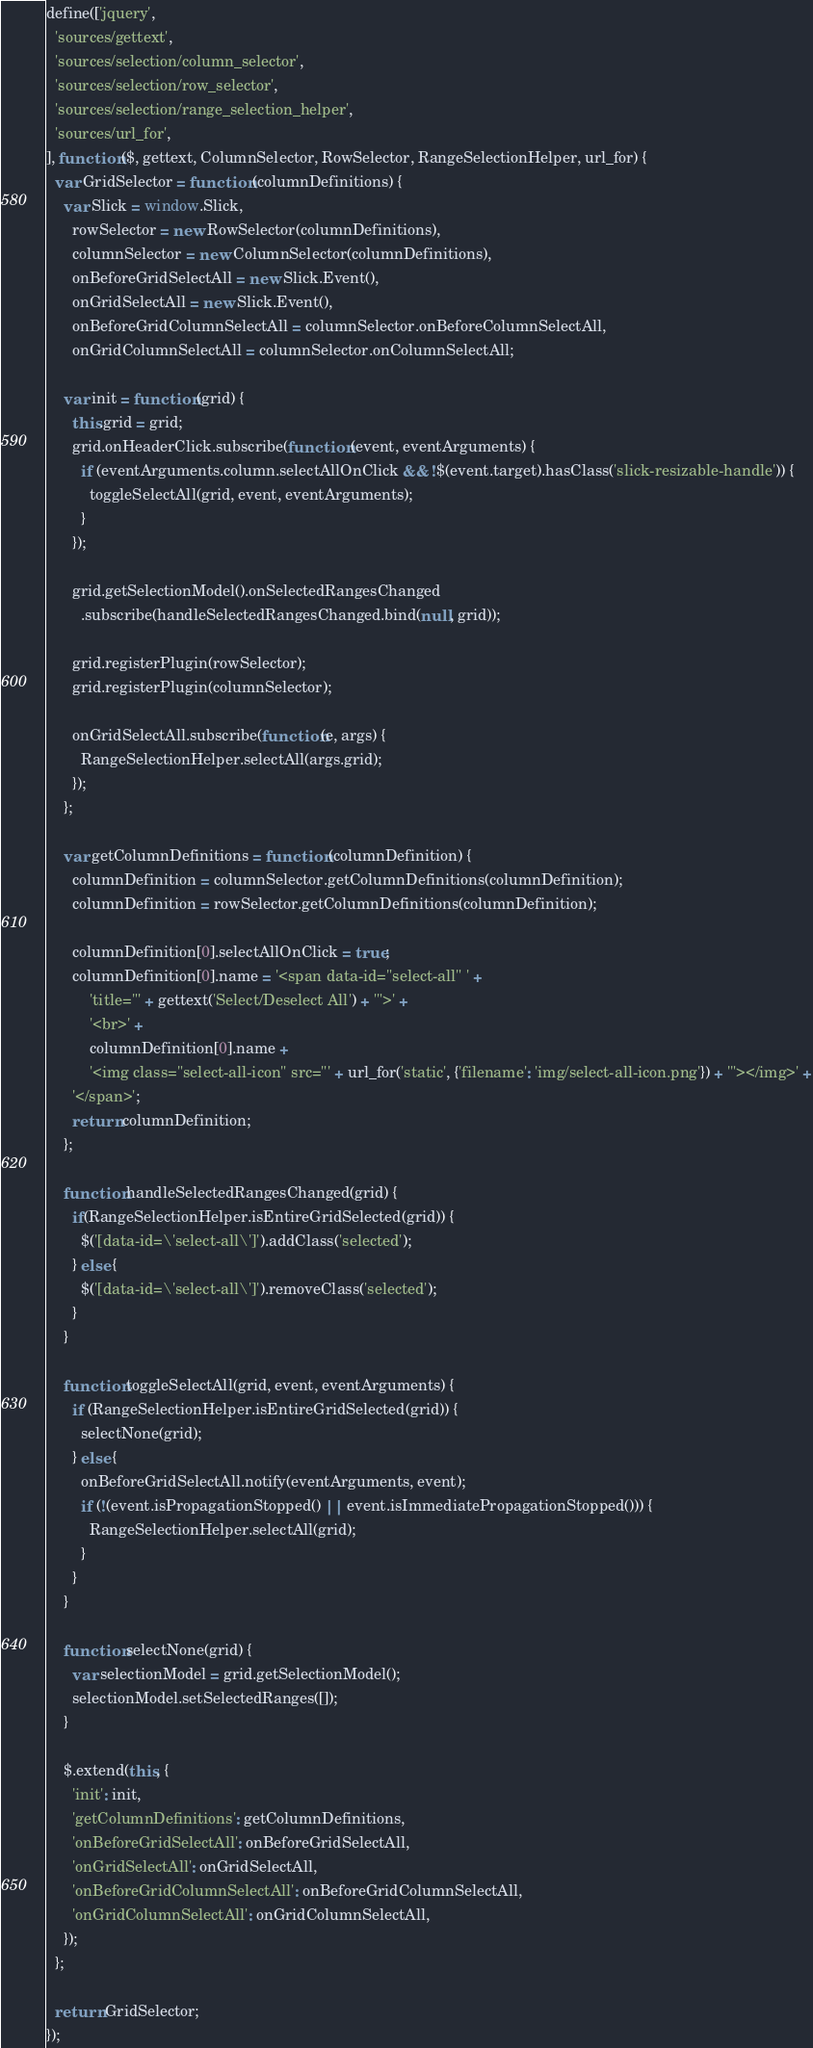Convert code to text. <code><loc_0><loc_0><loc_500><loc_500><_JavaScript_>
define(['jquery',
  'sources/gettext',
  'sources/selection/column_selector',
  'sources/selection/row_selector',
  'sources/selection/range_selection_helper',
  'sources/url_for',
], function ($, gettext, ColumnSelector, RowSelector, RangeSelectionHelper, url_for) {
  var GridSelector = function (columnDefinitions) {
    var Slick = window.Slick,
      rowSelector = new RowSelector(columnDefinitions),
      columnSelector = new ColumnSelector(columnDefinitions),
      onBeforeGridSelectAll = new Slick.Event(),
      onGridSelectAll = new Slick.Event(),
      onBeforeGridColumnSelectAll = columnSelector.onBeforeColumnSelectAll,
      onGridColumnSelectAll = columnSelector.onColumnSelectAll;

    var init = function (grid) {
      this.grid = grid;
      grid.onHeaderClick.subscribe(function (event, eventArguments) {
        if (eventArguments.column.selectAllOnClick && !$(event.target).hasClass('slick-resizable-handle')) {
          toggleSelectAll(grid, event, eventArguments);
        }
      });

      grid.getSelectionModel().onSelectedRangesChanged
        .subscribe(handleSelectedRangesChanged.bind(null, grid));

      grid.registerPlugin(rowSelector);
      grid.registerPlugin(columnSelector);

      onGridSelectAll.subscribe(function(e, args) {
        RangeSelectionHelper.selectAll(args.grid);
      });
    };

    var getColumnDefinitions = function (columnDefinition) {
      columnDefinition = columnSelector.getColumnDefinitions(columnDefinition);
      columnDefinition = rowSelector.getColumnDefinitions(columnDefinition);

      columnDefinition[0].selectAllOnClick = true;
      columnDefinition[0].name = '<span data-id="select-all" ' +
          'title="' + gettext('Select/Deselect All') + '">' +
          '<br>' +
          columnDefinition[0].name +
          '<img class="select-all-icon" src="' + url_for('static', {'filename': 'img/select-all-icon.png'}) + '"></img>' +
      '</span>';
      return columnDefinition;
    };

    function handleSelectedRangesChanged(grid) {
      if(RangeSelectionHelper.isEntireGridSelected(grid)) {
        $('[data-id=\'select-all\']').addClass('selected');
      } else {
        $('[data-id=\'select-all\']').removeClass('selected');
      }
    }

    function toggleSelectAll(grid, event, eventArguments) {
      if (RangeSelectionHelper.isEntireGridSelected(grid)) {
        selectNone(grid);
      } else {
        onBeforeGridSelectAll.notify(eventArguments, event);
        if (!(event.isPropagationStopped() || event.isImmediatePropagationStopped())) {
          RangeSelectionHelper.selectAll(grid);
        }
      }
    }

    function selectNone(grid) {
      var selectionModel = grid.getSelectionModel();
      selectionModel.setSelectedRanges([]);
    }

    $.extend(this, {
      'init': init,
      'getColumnDefinitions': getColumnDefinitions,
      'onBeforeGridSelectAll': onBeforeGridSelectAll,
      'onGridSelectAll': onGridSelectAll,
      'onBeforeGridColumnSelectAll': onBeforeGridColumnSelectAll,
      'onGridColumnSelectAll': onGridColumnSelectAll,
    });
  };

  return GridSelector;
});
</code> 